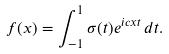<formula> <loc_0><loc_0><loc_500><loc_500>f ( x ) = \int _ { - 1 } ^ { 1 } \sigma ( t ) e ^ { i c x t } \, d t .</formula> 